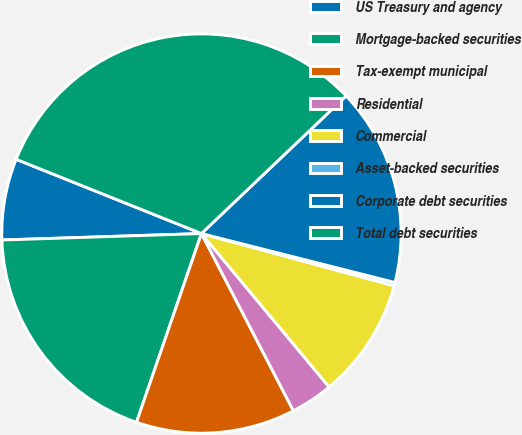Convert chart. <chart><loc_0><loc_0><loc_500><loc_500><pie_chart><fcel>US Treasury and agency<fcel>Mortgage-backed securities<fcel>Tax-exempt municipal<fcel>Residential<fcel>Commercial<fcel>Asset-backed securities<fcel>Corporate debt securities<fcel>Total debt securities<nl><fcel>6.58%<fcel>19.21%<fcel>12.89%<fcel>3.43%<fcel>9.74%<fcel>0.27%<fcel>16.05%<fcel>31.83%<nl></chart> 